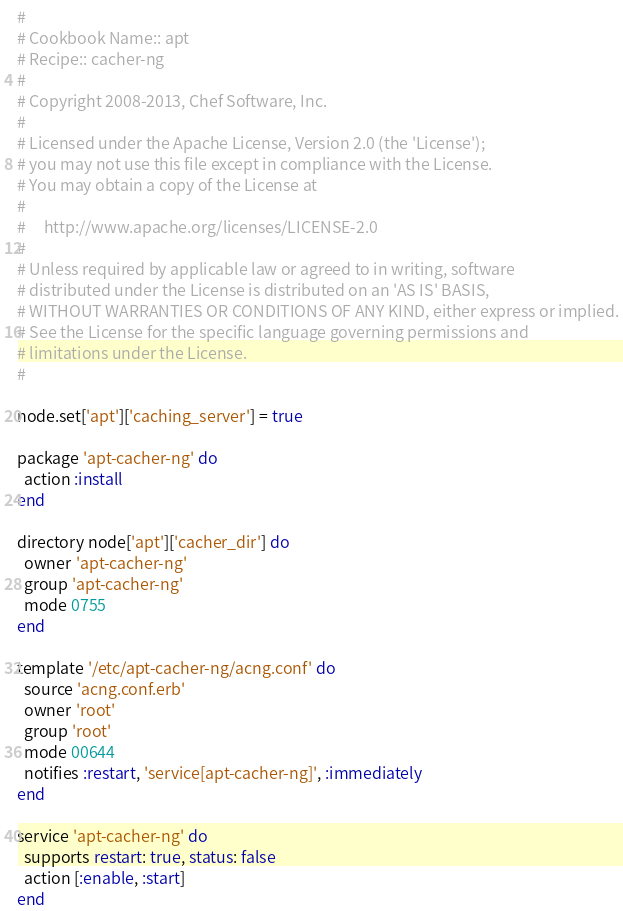<code> <loc_0><loc_0><loc_500><loc_500><_Ruby_>#
# Cookbook Name:: apt
# Recipe:: cacher-ng
#
# Copyright 2008-2013, Chef Software, Inc.
#
# Licensed under the Apache License, Version 2.0 (the 'License');
# you may not use this file except in compliance with the License.
# You may obtain a copy of the License at
#
#     http://www.apache.org/licenses/LICENSE-2.0
#
# Unless required by applicable law or agreed to in writing, software
# distributed under the License is distributed on an 'AS IS' BASIS,
# WITHOUT WARRANTIES OR CONDITIONS OF ANY KIND, either express or implied.
# See the License for the specific language governing permissions and
# limitations under the License.
#

node.set['apt']['caching_server'] = true

package 'apt-cacher-ng' do
  action :install
end

directory node['apt']['cacher_dir'] do
  owner 'apt-cacher-ng'
  group 'apt-cacher-ng'
  mode 0755
end

template '/etc/apt-cacher-ng/acng.conf' do
  source 'acng.conf.erb'
  owner 'root'
  group 'root'
  mode 00644
  notifies :restart, 'service[apt-cacher-ng]', :immediately
end

service 'apt-cacher-ng' do
  supports restart: true, status: false
  action [:enable, :start]
end
</code> 